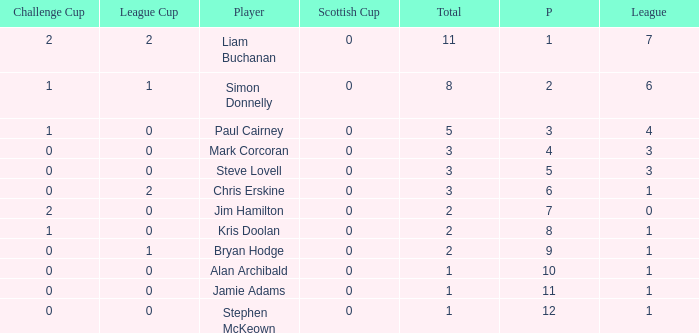How many points did player 7 score in the challenge cup? 1.0. 